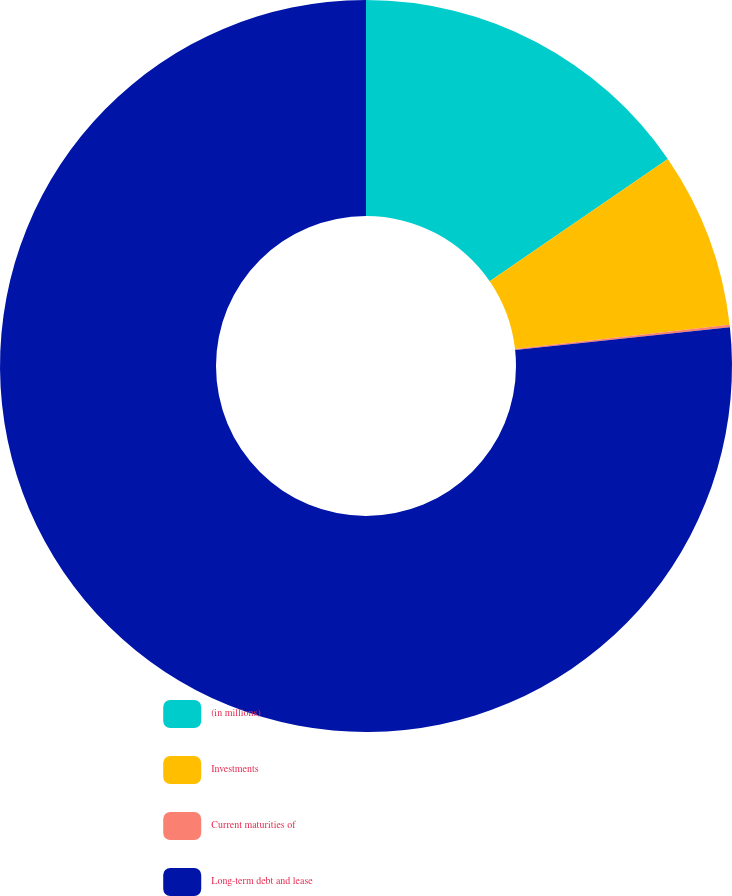Convert chart. <chart><loc_0><loc_0><loc_500><loc_500><pie_chart><fcel>(in millions)<fcel>Investments<fcel>Current maturities of<fcel>Long-term debt and lease<nl><fcel>15.43%<fcel>7.77%<fcel>0.11%<fcel>76.69%<nl></chart> 